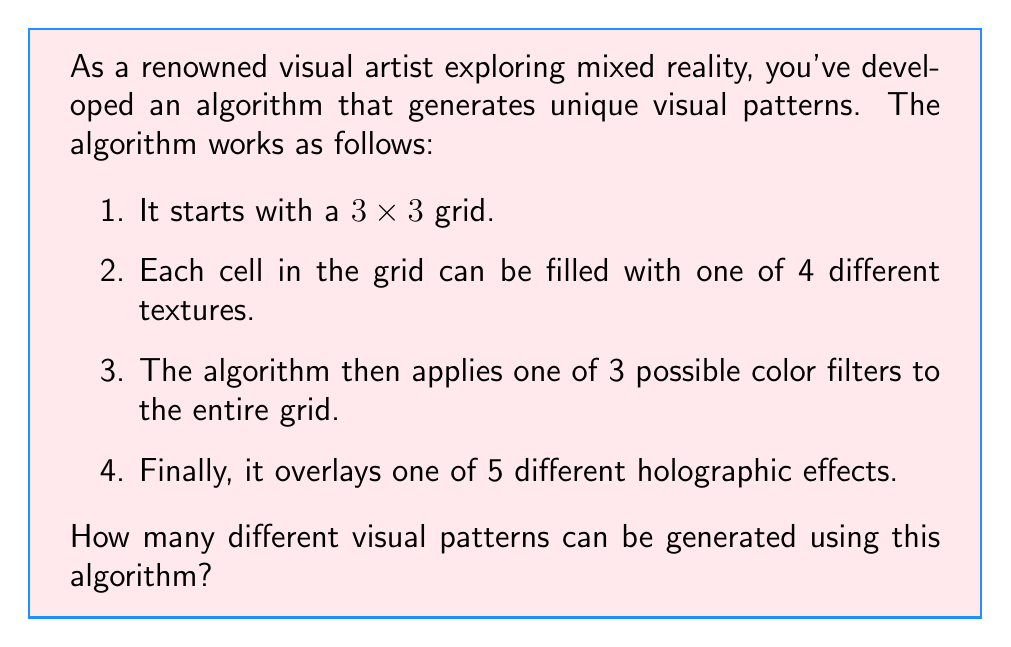Give your solution to this math problem. To solve this problem, we'll use the multiplication principle of counting. We'll break down the problem into its components and multiply the number of possibilities for each step:

1. Grid filling:
   - We have a 3x3 grid, which means 9 cells.
   - Each cell can be filled with one of 4 textures.
   - The number of ways to fill the grid is $4^9$, as we make 9 independent choices, each with 4 options.

2. Color filters:
   - There are 3 possible color filters to choose from.

3. Holographic effects:
   - There are 5 different holographic effects to choose from.

Now, we multiply these together:

$$ \text{Total patterns} = 4^9 \times 3 \times 5 $$

Calculating this:
$$ 4^9 = 262,144 $$
$$ 262,144 \times 3 = 786,432 $$
$$ 786,432 \times 5 = 3,932,160 $$

Therefore, the total number of different visual patterns that can be generated is 3,932,160.
Answer: $3,932,160$ different visual patterns 